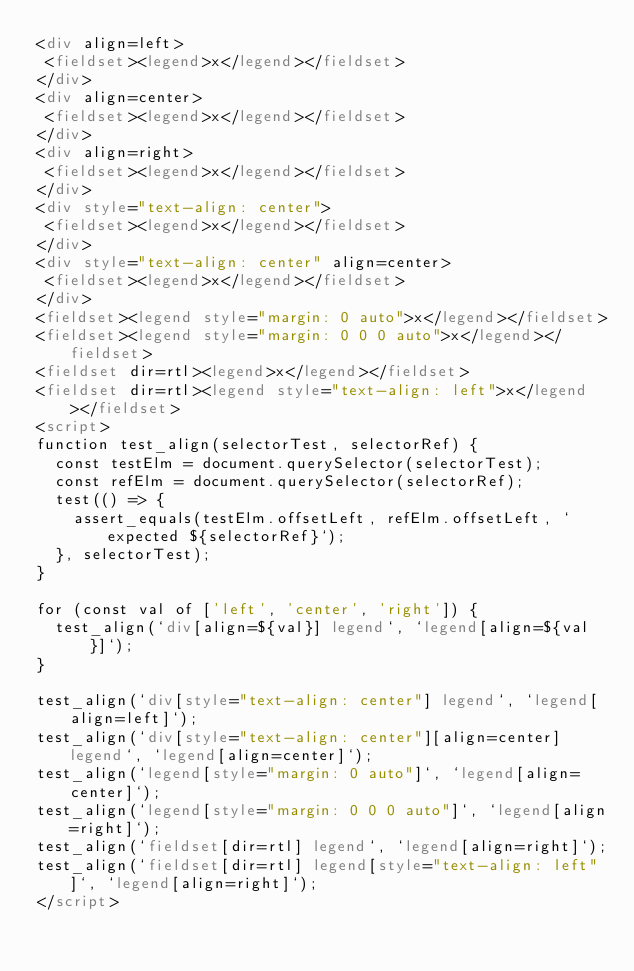<code> <loc_0><loc_0><loc_500><loc_500><_HTML_><div align=left>
 <fieldset><legend>x</legend></fieldset>
</div>
<div align=center>
 <fieldset><legend>x</legend></fieldset>
</div>
<div align=right>
 <fieldset><legend>x</legend></fieldset>
</div>
<div style="text-align: center">
 <fieldset><legend>x</legend></fieldset>
</div>
<div style="text-align: center" align=center>
 <fieldset><legend>x</legend></fieldset>
</div>
<fieldset><legend style="margin: 0 auto">x</legend></fieldset>
<fieldset><legend style="margin: 0 0 0 auto">x</legend></fieldset>
<fieldset dir=rtl><legend>x</legend></fieldset>
<fieldset dir=rtl><legend style="text-align: left">x</legend></fieldset>
<script>
function test_align(selectorTest, selectorRef) {
  const testElm = document.querySelector(selectorTest);
  const refElm = document.querySelector(selectorRef);
  test(() => {
    assert_equals(testElm.offsetLeft, refElm.offsetLeft, `expected ${selectorRef}`);
  }, selectorTest);
}

for (const val of ['left', 'center', 'right']) {
  test_align(`div[align=${val}] legend`, `legend[align=${val}]`);
}

test_align(`div[style="text-align: center"] legend`, `legend[align=left]`);
test_align(`div[style="text-align: center"][align=center] legend`, `legend[align=center]`);
test_align(`legend[style="margin: 0 auto"]`, `legend[align=center]`);
test_align(`legend[style="margin: 0 0 0 auto"]`, `legend[align=right]`);
test_align(`fieldset[dir=rtl] legend`, `legend[align=right]`);
test_align(`fieldset[dir=rtl] legend[style="text-align: left"]`, `legend[align=right]`);
</script>
</code> 